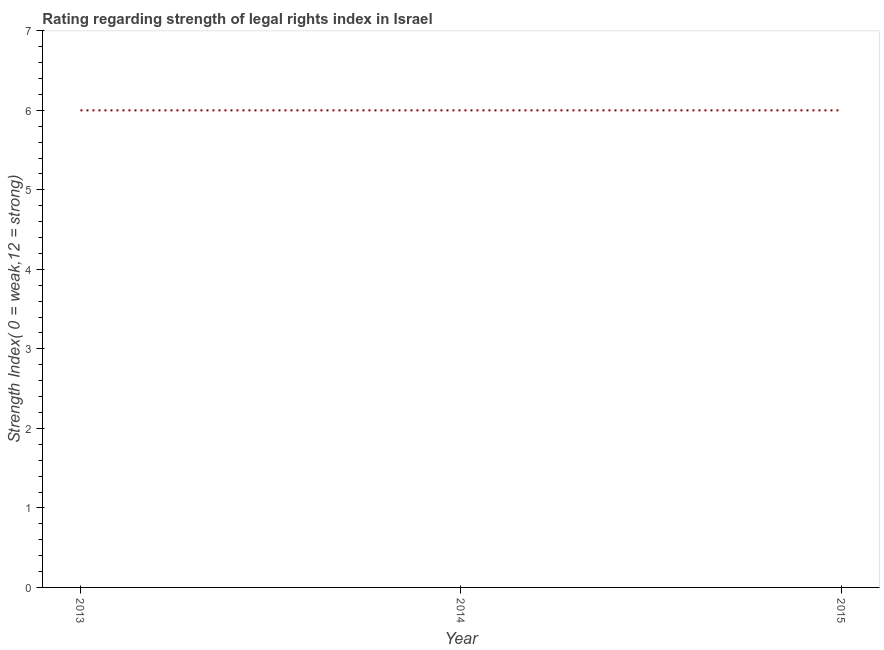What is the strength of legal rights index in 2015?
Give a very brief answer. 6. Across all years, what is the maximum strength of legal rights index?
Your response must be concise. 6. Across all years, what is the minimum strength of legal rights index?
Offer a very short reply. 6. In which year was the strength of legal rights index maximum?
Your response must be concise. 2013. What is the sum of the strength of legal rights index?
Provide a succinct answer. 18. What is the difference between the strength of legal rights index in 2014 and 2015?
Keep it short and to the point. 0. What is the average strength of legal rights index per year?
Your answer should be very brief. 6. What is the median strength of legal rights index?
Your response must be concise. 6. In how many years, is the strength of legal rights index greater than 1.4 ?
Ensure brevity in your answer.  3. Do a majority of the years between 2015 and 2014 (inclusive) have strength of legal rights index greater than 1.4 ?
Provide a succinct answer. No. Is the difference between the strength of legal rights index in 2013 and 2015 greater than the difference between any two years?
Offer a terse response. Yes. What is the difference between the highest and the second highest strength of legal rights index?
Offer a terse response. 0. Is the sum of the strength of legal rights index in 2014 and 2015 greater than the maximum strength of legal rights index across all years?
Give a very brief answer. Yes. What is the difference between the highest and the lowest strength of legal rights index?
Offer a terse response. 0. In how many years, is the strength of legal rights index greater than the average strength of legal rights index taken over all years?
Offer a terse response. 0. How many lines are there?
Offer a terse response. 1. What is the difference between two consecutive major ticks on the Y-axis?
Provide a short and direct response. 1. Are the values on the major ticks of Y-axis written in scientific E-notation?
Offer a terse response. No. What is the title of the graph?
Give a very brief answer. Rating regarding strength of legal rights index in Israel. What is the label or title of the Y-axis?
Offer a very short reply. Strength Index( 0 = weak,12 = strong). What is the Strength Index( 0 = weak,12 = strong) of 2013?
Give a very brief answer. 6. What is the Strength Index( 0 = weak,12 = strong) in 2014?
Your answer should be compact. 6. What is the Strength Index( 0 = weak,12 = strong) of 2015?
Provide a short and direct response. 6. What is the difference between the Strength Index( 0 = weak,12 = strong) in 2013 and 2014?
Ensure brevity in your answer.  0. What is the difference between the Strength Index( 0 = weak,12 = strong) in 2013 and 2015?
Make the answer very short. 0. What is the ratio of the Strength Index( 0 = weak,12 = strong) in 2014 to that in 2015?
Offer a very short reply. 1. 